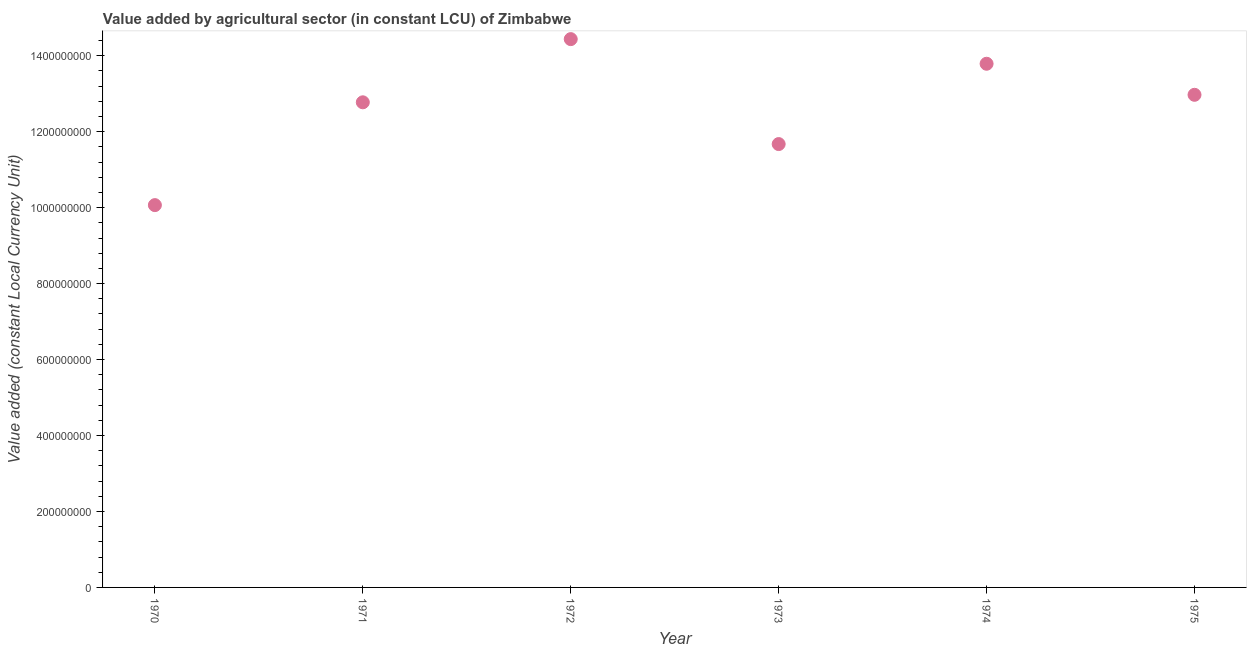What is the value added by agriculture sector in 1974?
Provide a succinct answer. 1.38e+09. Across all years, what is the maximum value added by agriculture sector?
Make the answer very short. 1.44e+09. Across all years, what is the minimum value added by agriculture sector?
Your answer should be compact. 1.01e+09. In which year was the value added by agriculture sector maximum?
Your answer should be compact. 1972. In which year was the value added by agriculture sector minimum?
Provide a short and direct response. 1970. What is the sum of the value added by agriculture sector?
Provide a succinct answer. 7.57e+09. What is the difference between the value added by agriculture sector in 1973 and 1975?
Provide a short and direct response. -1.30e+08. What is the average value added by agriculture sector per year?
Provide a short and direct response. 1.26e+09. What is the median value added by agriculture sector?
Provide a short and direct response. 1.29e+09. Do a majority of the years between 1975 and 1972 (inclusive) have value added by agriculture sector greater than 1000000000 LCU?
Make the answer very short. Yes. What is the ratio of the value added by agriculture sector in 1970 to that in 1975?
Keep it short and to the point. 0.78. What is the difference between the highest and the second highest value added by agriculture sector?
Provide a succinct answer. 6.49e+07. What is the difference between the highest and the lowest value added by agriculture sector?
Offer a terse response. 4.37e+08. How many dotlines are there?
Offer a very short reply. 1. How many years are there in the graph?
Keep it short and to the point. 6. Are the values on the major ticks of Y-axis written in scientific E-notation?
Ensure brevity in your answer.  No. Does the graph contain any zero values?
Offer a very short reply. No. Does the graph contain grids?
Give a very brief answer. No. What is the title of the graph?
Keep it short and to the point. Value added by agricultural sector (in constant LCU) of Zimbabwe. What is the label or title of the Y-axis?
Your response must be concise. Value added (constant Local Currency Unit). What is the Value added (constant Local Currency Unit) in 1970?
Offer a terse response. 1.01e+09. What is the Value added (constant Local Currency Unit) in 1971?
Keep it short and to the point. 1.28e+09. What is the Value added (constant Local Currency Unit) in 1972?
Keep it short and to the point. 1.44e+09. What is the Value added (constant Local Currency Unit) in 1973?
Your answer should be compact. 1.17e+09. What is the Value added (constant Local Currency Unit) in 1974?
Your answer should be compact. 1.38e+09. What is the Value added (constant Local Currency Unit) in 1975?
Your answer should be very brief. 1.30e+09. What is the difference between the Value added (constant Local Currency Unit) in 1970 and 1971?
Keep it short and to the point. -2.71e+08. What is the difference between the Value added (constant Local Currency Unit) in 1970 and 1972?
Your response must be concise. -4.37e+08. What is the difference between the Value added (constant Local Currency Unit) in 1970 and 1973?
Ensure brevity in your answer.  -1.61e+08. What is the difference between the Value added (constant Local Currency Unit) in 1970 and 1974?
Give a very brief answer. -3.72e+08. What is the difference between the Value added (constant Local Currency Unit) in 1970 and 1975?
Your answer should be compact. -2.90e+08. What is the difference between the Value added (constant Local Currency Unit) in 1971 and 1972?
Your response must be concise. -1.66e+08. What is the difference between the Value added (constant Local Currency Unit) in 1971 and 1973?
Provide a succinct answer. 1.10e+08. What is the difference between the Value added (constant Local Currency Unit) in 1971 and 1974?
Your answer should be very brief. -1.02e+08. What is the difference between the Value added (constant Local Currency Unit) in 1971 and 1975?
Your response must be concise. -1.97e+07. What is the difference between the Value added (constant Local Currency Unit) in 1972 and 1973?
Provide a short and direct response. 2.76e+08. What is the difference between the Value added (constant Local Currency Unit) in 1972 and 1974?
Give a very brief answer. 6.49e+07. What is the difference between the Value added (constant Local Currency Unit) in 1972 and 1975?
Your answer should be compact. 1.47e+08. What is the difference between the Value added (constant Local Currency Unit) in 1973 and 1974?
Give a very brief answer. -2.11e+08. What is the difference between the Value added (constant Local Currency Unit) in 1973 and 1975?
Ensure brevity in your answer.  -1.30e+08. What is the difference between the Value added (constant Local Currency Unit) in 1974 and 1975?
Offer a terse response. 8.18e+07. What is the ratio of the Value added (constant Local Currency Unit) in 1970 to that in 1971?
Offer a very short reply. 0.79. What is the ratio of the Value added (constant Local Currency Unit) in 1970 to that in 1972?
Provide a succinct answer. 0.7. What is the ratio of the Value added (constant Local Currency Unit) in 1970 to that in 1973?
Ensure brevity in your answer.  0.86. What is the ratio of the Value added (constant Local Currency Unit) in 1970 to that in 1974?
Give a very brief answer. 0.73. What is the ratio of the Value added (constant Local Currency Unit) in 1970 to that in 1975?
Offer a very short reply. 0.78. What is the ratio of the Value added (constant Local Currency Unit) in 1971 to that in 1972?
Your response must be concise. 0.89. What is the ratio of the Value added (constant Local Currency Unit) in 1971 to that in 1973?
Provide a short and direct response. 1.09. What is the ratio of the Value added (constant Local Currency Unit) in 1971 to that in 1974?
Your response must be concise. 0.93. What is the ratio of the Value added (constant Local Currency Unit) in 1971 to that in 1975?
Give a very brief answer. 0.98. What is the ratio of the Value added (constant Local Currency Unit) in 1972 to that in 1973?
Your answer should be very brief. 1.24. What is the ratio of the Value added (constant Local Currency Unit) in 1972 to that in 1974?
Provide a short and direct response. 1.05. What is the ratio of the Value added (constant Local Currency Unit) in 1972 to that in 1975?
Offer a terse response. 1.11. What is the ratio of the Value added (constant Local Currency Unit) in 1973 to that in 1974?
Give a very brief answer. 0.85. What is the ratio of the Value added (constant Local Currency Unit) in 1973 to that in 1975?
Ensure brevity in your answer.  0.9. What is the ratio of the Value added (constant Local Currency Unit) in 1974 to that in 1975?
Give a very brief answer. 1.06. 